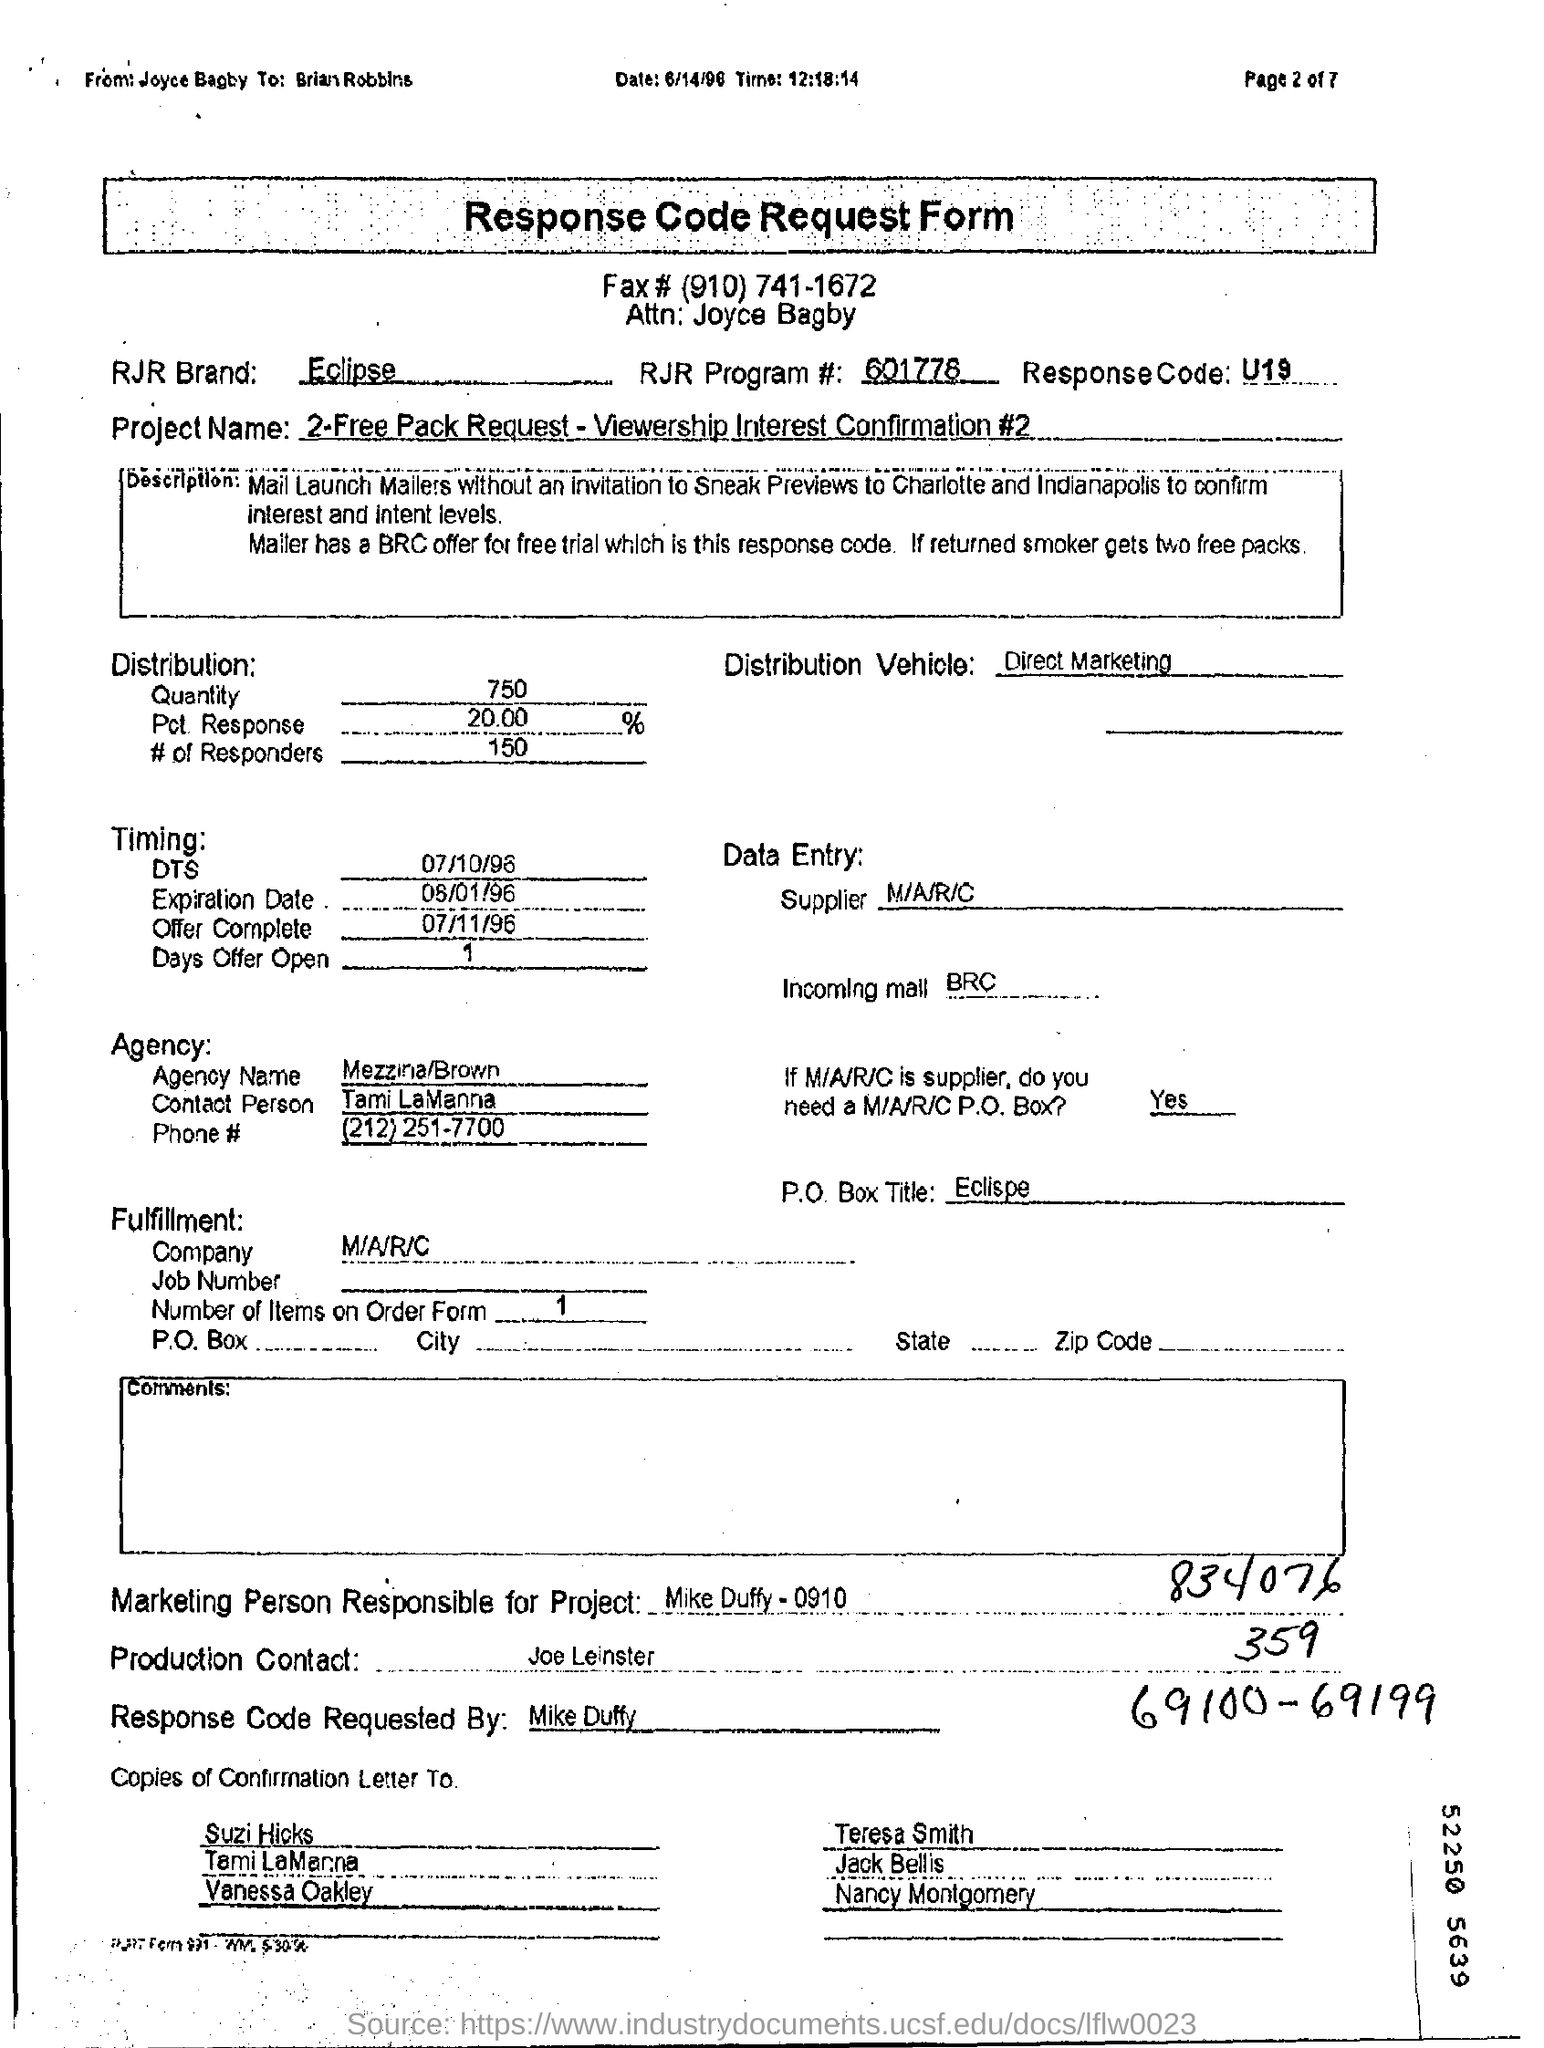Who is the person for the attention?
Your response must be concise. Joyce Bagby. What is the name of the rjr brand?
Your response must be concise. Eclipse. What is the rjr program code#?
Ensure brevity in your answer.  601778. What is the response code ?
Provide a short and direct response. U19. What is the name of agency ?
Offer a very short reply. Mezzina/ Brown. What is the name of the person for production contact?
Ensure brevity in your answer.  Joe Leinster. 